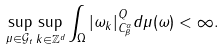<formula> <loc_0><loc_0><loc_500><loc_500>\sup _ { \mu \in \mathcal { G } _ { t } } \sup _ { k \in \mathbb { Z } ^ { d } } \int _ { \Omega } | \omega _ { k } | _ { C _ { \beta } ^ { \alpha } } ^ { Q } d \mu ( \omega ) < \infty .</formula> 